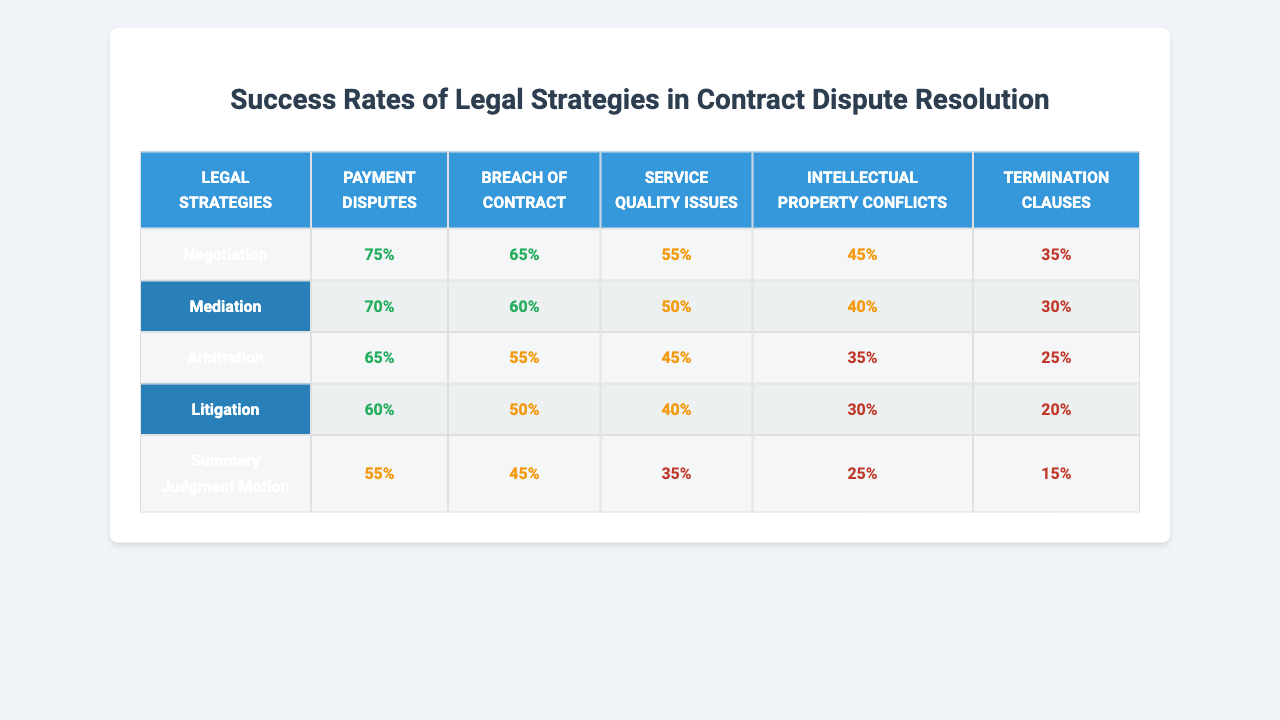What is the success rate of mediation for payment disputes? According to the table, the success rate of mediation for payment disputes is 70%.
Answer: 70% Which legal strategy has the highest success rate for breach of contract cases? Looking at the table, negotiation has the highest success rate for breach of contract cases at 65%.
Answer: 65% What is the success rate of arbitration for intellectual property conflicts? The table shows that the success rate of arbitration for intellectual property conflicts is 35%.
Answer: 35% Is the success rate of litigation lower than that of summary judgment motion for service quality issues? In the table, litigation has a success rate of 40%, while the summary judgment motion has a success rate of 35%. Therefore, yes, litigation's success rate is higher.
Answer: Yes What is the average success rate across all legal strategies for termination clauses? To find the average, sum the success rates for termination clauses (35 + 30 + 25 + 20 + 15 = 125) and divide by the number of strategies (5). The average success rate is 25%.
Answer: 25% Which legal strategy has the lowest success rate for breach of contract? Checking the table reveals that the strategy with the lowest success rate for breach of contract is the summary judgment motion, with a success rate of 30%.
Answer: 30% How do the success rates of negotiation and mediation for payment disputes compare? Negotiation has a success rate of 75%, while mediation has a success rate of 70%. Thus, negotiation has a higher success rate by 5%.
Answer: Negotiation is higher by 5% If you consider only service quality issues, which strategy offers the best chance of success? The success rates for service quality issues are 55% for mediation, 45% for arbitration, 40% for litigation, 35% for negotiation, and 25% for summary judgment motion. Mediation has the highest at 55%.
Answer: Mediation What is the total success rate of all strategies for breach of contract? By summing the success rates for breach of contract (65 + 60 + 55 + 50 + 45 = 275), we find the total success rate is 275%.
Answer: 275% Is the difference in success rates between negotiation and litigation for payment disputes greater than 20%? Negotiation has a success rate of 75% and litigation has a success rate of 60%. The difference is 15%, which is not greater than 20%.
Answer: No 